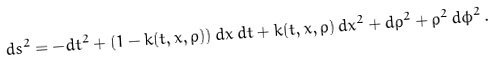<formula> <loc_0><loc_0><loc_500><loc_500>d s ^ { 2 } = - d t ^ { 2 } + ( 1 - k ( t , x , \rho ) ) \, d x \, d t + k ( t , x , \rho ) \, d x ^ { 2 } + d { \rho } ^ { 2 } + { \rho } ^ { 2 } \, d { \phi } ^ { 2 } \, .</formula> 